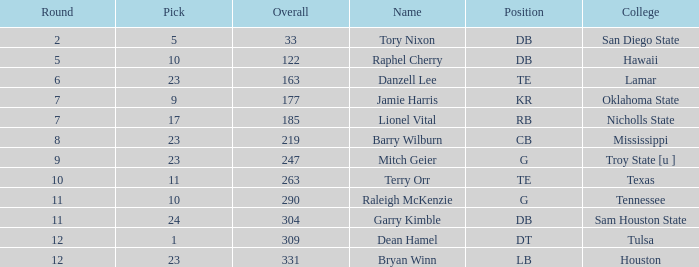How many selections have a college of hawaii and a total less than 122? 0.0. 